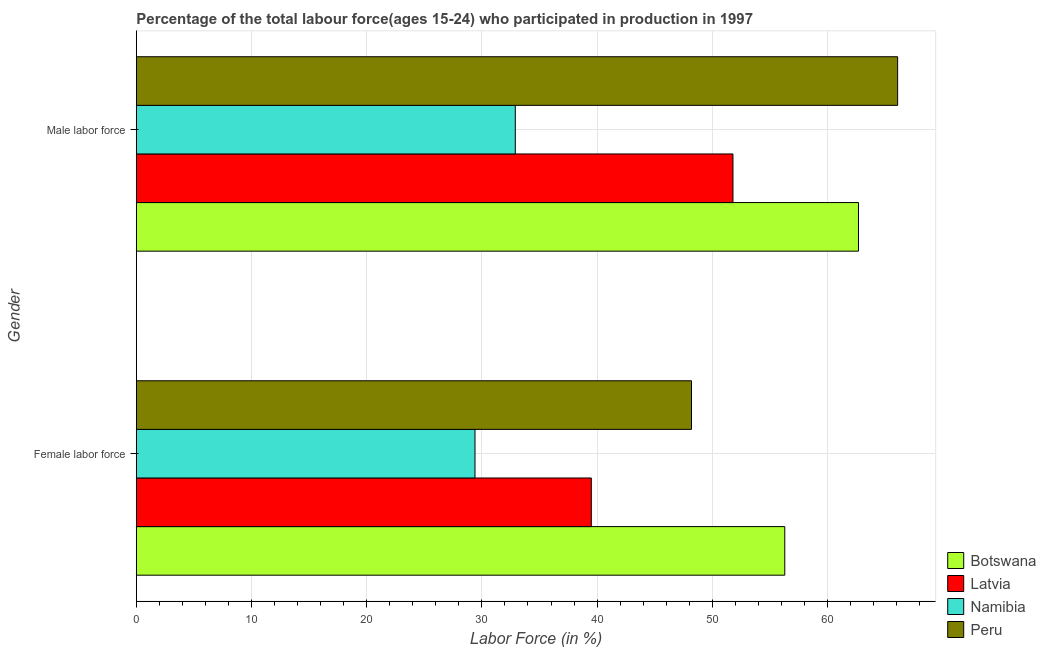Are the number of bars per tick equal to the number of legend labels?
Keep it short and to the point. Yes. How many bars are there on the 2nd tick from the top?
Your answer should be very brief. 4. How many bars are there on the 2nd tick from the bottom?
Provide a succinct answer. 4. What is the label of the 1st group of bars from the top?
Make the answer very short. Male labor force. What is the percentage of female labor force in Botswana?
Your answer should be very brief. 56.3. Across all countries, what is the maximum percentage of female labor force?
Give a very brief answer. 56.3. Across all countries, what is the minimum percentage of female labor force?
Ensure brevity in your answer.  29.4. In which country was the percentage of female labor force maximum?
Provide a succinct answer. Botswana. In which country was the percentage of female labor force minimum?
Your answer should be very brief. Namibia. What is the total percentage of male labour force in the graph?
Your response must be concise. 213.5. What is the difference between the percentage of female labor force in Botswana and that in Namibia?
Offer a very short reply. 26.9. What is the difference between the percentage of male labour force in Latvia and the percentage of female labor force in Namibia?
Keep it short and to the point. 22.4. What is the average percentage of female labor force per country?
Offer a terse response. 43.35. What is the difference between the percentage of female labor force and percentage of male labour force in Peru?
Your answer should be compact. -17.9. What is the ratio of the percentage of female labor force in Peru to that in Botswana?
Offer a terse response. 0.86. What does the 4th bar from the top in Male labor force represents?
Provide a short and direct response. Botswana. What does the 4th bar from the bottom in Male labor force represents?
Provide a short and direct response. Peru. How many bars are there?
Offer a terse response. 8. Are all the bars in the graph horizontal?
Ensure brevity in your answer.  Yes. How many countries are there in the graph?
Offer a very short reply. 4. What is the difference between two consecutive major ticks on the X-axis?
Ensure brevity in your answer.  10. Are the values on the major ticks of X-axis written in scientific E-notation?
Provide a succinct answer. No. Does the graph contain any zero values?
Your response must be concise. No. Does the graph contain grids?
Ensure brevity in your answer.  Yes. Where does the legend appear in the graph?
Provide a succinct answer. Bottom right. How many legend labels are there?
Provide a short and direct response. 4. How are the legend labels stacked?
Your answer should be very brief. Vertical. What is the title of the graph?
Offer a very short reply. Percentage of the total labour force(ages 15-24) who participated in production in 1997. Does "Iran" appear as one of the legend labels in the graph?
Make the answer very short. No. What is the label or title of the X-axis?
Provide a succinct answer. Labor Force (in %). What is the label or title of the Y-axis?
Provide a short and direct response. Gender. What is the Labor Force (in %) of Botswana in Female labor force?
Keep it short and to the point. 56.3. What is the Labor Force (in %) in Latvia in Female labor force?
Make the answer very short. 39.5. What is the Labor Force (in %) of Namibia in Female labor force?
Your answer should be very brief. 29.4. What is the Labor Force (in %) of Peru in Female labor force?
Keep it short and to the point. 48.2. What is the Labor Force (in %) in Botswana in Male labor force?
Provide a succinct answer. 62.7. What is the Labor Force (in %) of Latvia in Male labor force?
Offer a very short reply. 51.8. What is the Labor Force (in %) of Namibia in Male labor force?
Your answer should be very brief. 32.9. What is the Labor Force (in %) of Peru in Male labor force?
Offer a very short reply. 66.1. Across all Gender, what is the maximum Labor Force (in %) of Botswana?
Ensure brevity in your answer.  62.7. Across all Gender, what is the maximum Labor Force (in %) in Latvia?
Give a very brief answer. 51.8. Across all Gender, what is the maximum Labor Force (in %) in Namibia?
Offer a terse response. 32.9. Across all Gender, what is the maximum Labor Force (in %) in Peru?
Provide a succinct answer. 66.1. Across all Gender, what is the minimum Labor Force (in %) of Botswana?
Give a very brief answer. 56.3. Across all Gender, what is the minimum Labor Force (in %) of Latvia?
Keep it short and to the point. 39.5. Across all Gender, what is the minimum Labor Force (in %) of Namibia?
Give a very brief answer. 29.4. Across all Gender, what is the minimum Labor Force (in %) in Peru?
Keep it short and to the point. 48.2. What is the total Labor Force (in %) in Botswana in the graph?
Give a very brief answer. 119. What is the total Labor Force (in %) in Latvia in the graph?
Ensure brevity in your answer.  91.3. What is the total Labor Force (in %) in Namibia in the graph?
Keep it short and to the point. 62.3. What is the total Labor Force (in %) in Peru in the graph?
Provide a short and direct response. 114.3. What is the difference between the Labor Force (in %) in Latvia in Female labor force and that in Male labor force?
Ensure brevity in your answer.  -12.3. What is the difference between the Labor Force (in %) of Peru in Female labor force and that in Male labor force?
Offer a very short reply. -17.9. What is the difference between the Labor Force (in %) in Botswana in Female labor force and the Labor Force (in %) in Namibia in Male labor force?
Offer a very short reply. 23.4. What is the difference between the Labor Force (in %) in Latvia in Female labor force and the Labor Force (in %) in Peru in Male labor force?
Offer a very short reply. -26.6. What is the difference between the Labor Force (in %) of Namibia in Female labor force and the Labor Force (in %) of Peru in Male labor force?
Give a very brief answer. -36.7. What is the average Labor Force (in %) of Botswana per Gender?
Ensure brevity in your answer.  59.5. What is the average Labor Force (in %) of Latvia per Gender?
Your response must be concise. 45.65. What is the average Labor Force (in %) of Namibia per Gender?
Make the answer very short. 31.15. What is the average Labor Force (in %) in Peru per Gender?
Your response must be concise. 57.15. What is the difference between the Labor Force (in %) in Botswana and Labor Force (in %) in Namibia in Female labor force?
Provide a succinct answer. 26.9. What is the difference between the Labor Force (in %) of Latvia and Labor Force (in %) of Peru in Female labor force?
Offer a very short reply. -8.7. What is the difference between the Labor Force (in %) in Namibia and Labor Force (in %) in Peru in Female labor force?
Your response must be concise. -18.8. What is the difference between the Labor Force (in %) of Botswana and Labor Force (in %) of Latvia in Male labor force?
Offer a very short reply. 10.9. What is the difference between the Labor Force (in %) of Botswana and Labor Force (in %) of Namibia in Male labor force?
Ensure brevity in your answer.  29.8. What is the difference between the Labor Force (in %) of Latvia and Labor Force (in %) of Namibia in Male labor force?
Offer a terse response. 18.9. What is the difference between the Labor Force (in %) in Latvia and Labor Force (in %) in Peru in Male labor force?
Offer a very short reply. -14.3. What is the difference between the Labor Force (in %) in Namibia and Labor Force (in %) in Peru in Male labor force?
Provide a succinct answer. -33.2. What is the ratio of the Labor Force (in %) of Botswana in Female labor force to that in Male labor force?
Your response must be concise. 0.9. What is the ratio of the Labor Force (in %) of Latvia in Female labor force to that in Male labor force?
Your answer should be very brief. 0.76. What is the ratio of the Labor Force (in %) in Namibia in Female labor force to that in Male labor force?
Your response must be concise. 0.89. What is the ratio of the Labor Force (in %) in Peru in Female labor force to that in Male labor force?
Offer a very short reply. 0.73. What is the difference between the highest and the second highest Labor Force (in %) of Botswana?
Offer a terse response. 6.4. What is the difference between the highest and the second highest Labor Force (in %) in Namibia?
Offer a terse response. 3.5. What is the difference between the highest and the lowest Labor Force (in %) of Latvia?
Provide a succinct answer. 12.3. 